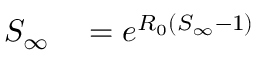<formula> <loc_0><loc_0><loc_500><loc_500>\begin{array} { r l } { S _ { \infty } } & = e ^ { R _ { 0 } ( S _ { \infty } - 1 ) } } \end{array}</formula> 